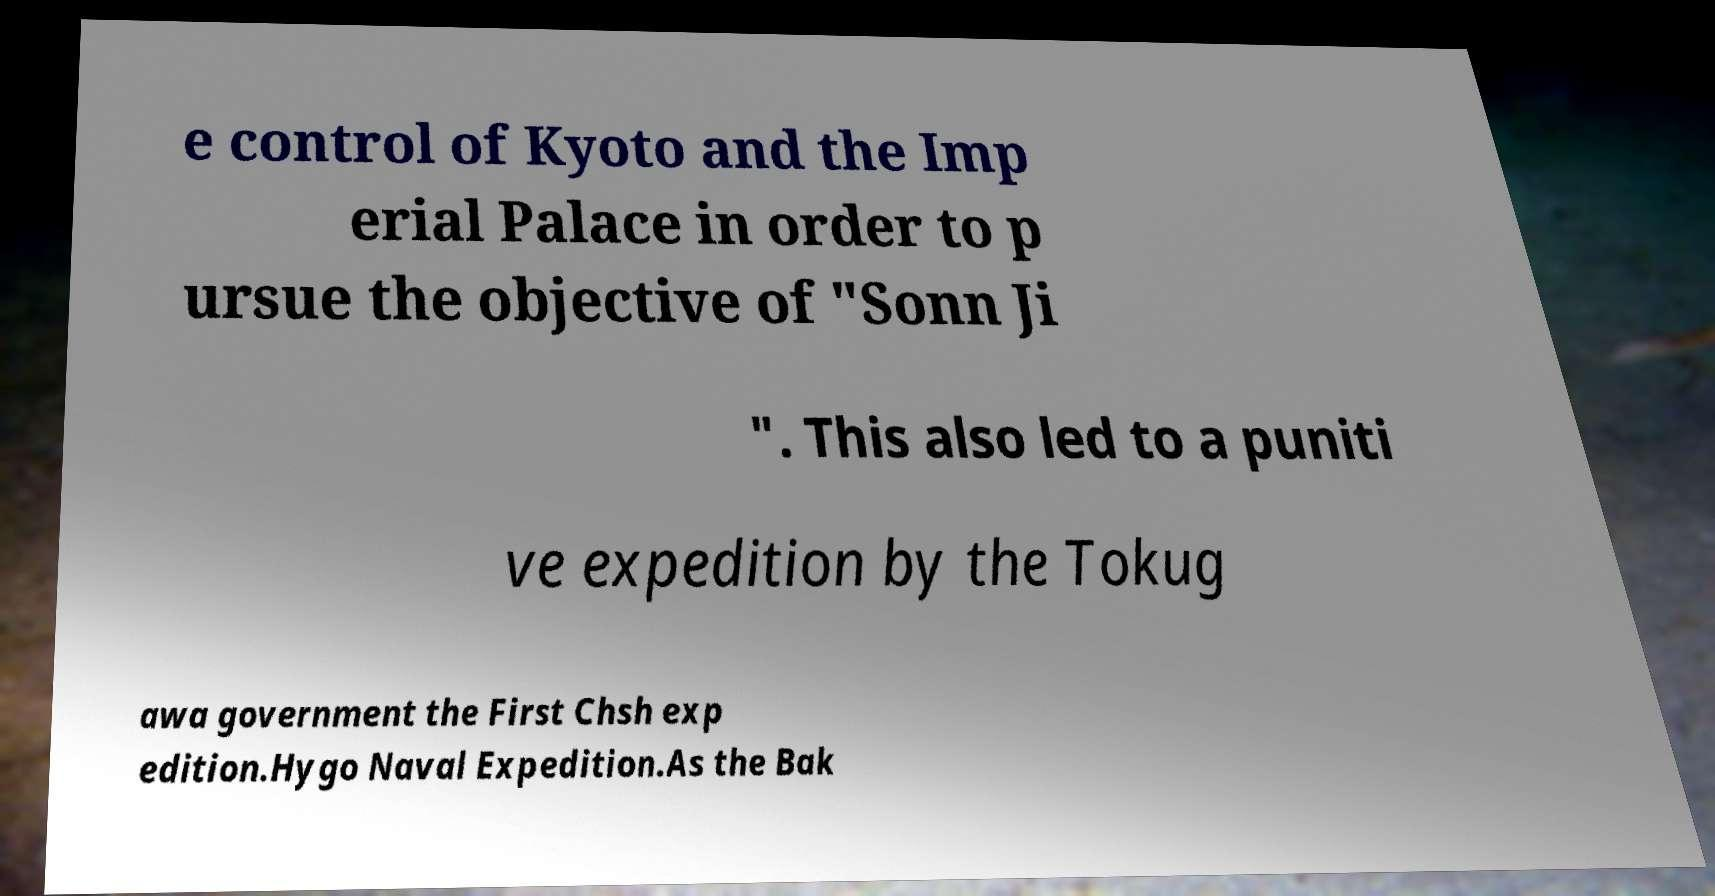Can you accurately transcribe the text from the provided image for me? e control of Kyoto and the Imp erial Palace in order to p ursue the objective of "Sonn Ji ". This also led to a puniti ve expedition by the Tokug awa government the First Chsh exp edition.Hygo Naval Expedition.As the Bak 